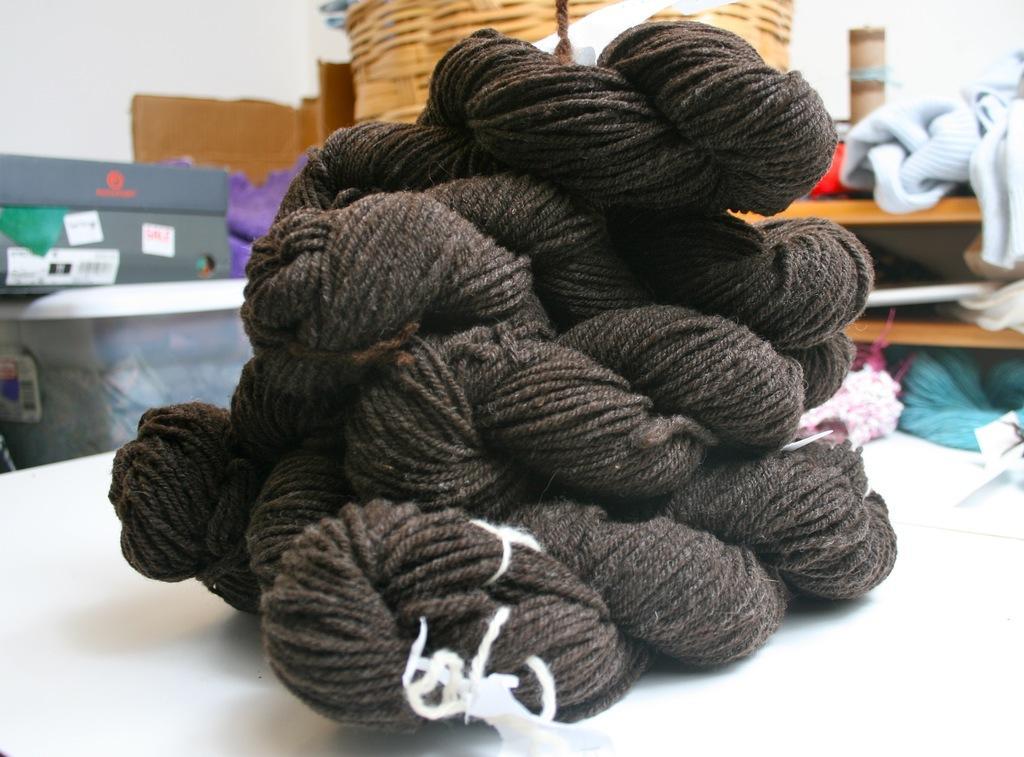How would you summarize this image in a sentence or two? In this image on a table there is wool. In the background there are woolen clothes, boxes, baskets and few other things are there. 